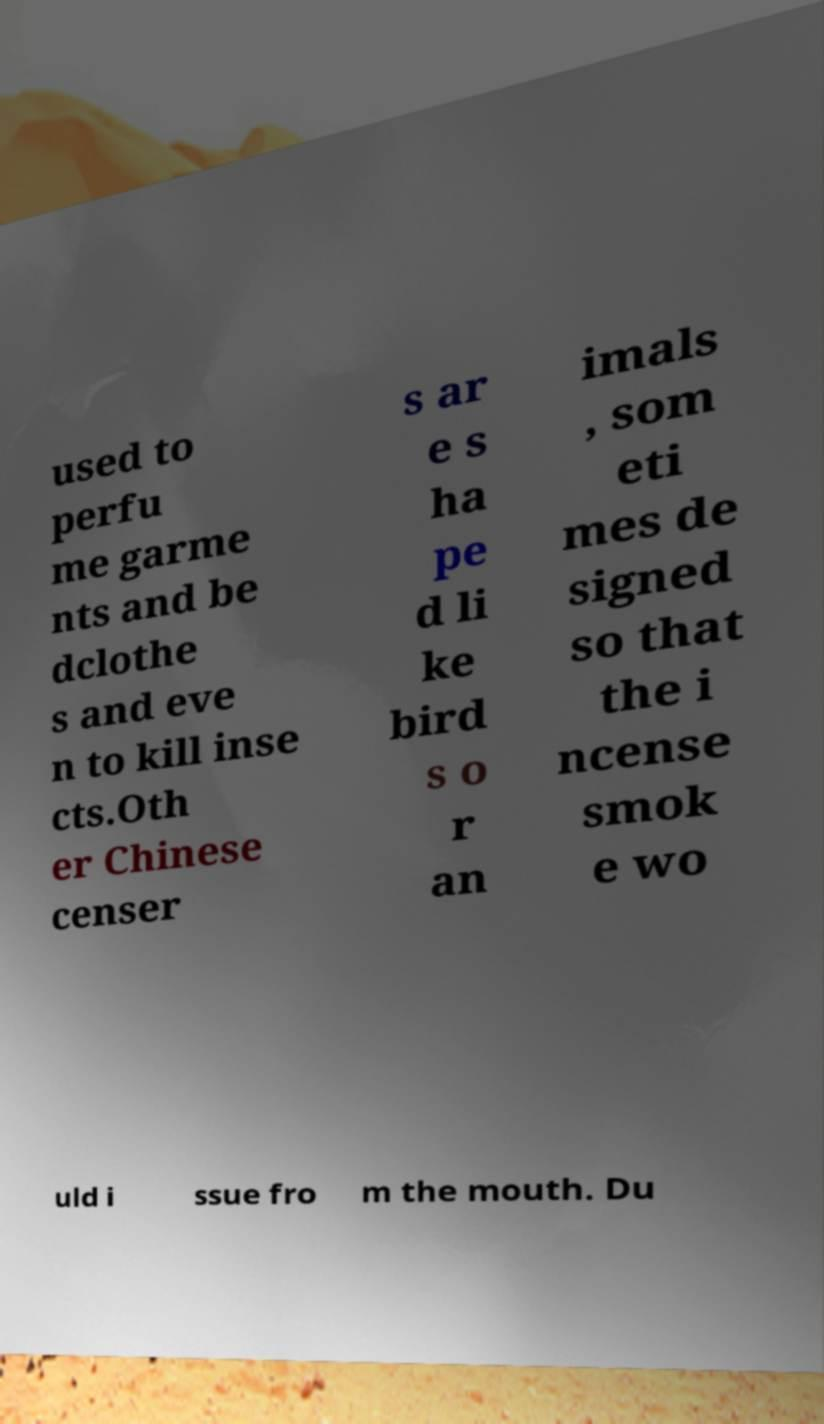Can you read and provide the text displayed in the image?This photo seems to have some interesting text. Can you extract and type it out for me? used to perfu me garme nts and be dclothe s and eve n to kill inse cts.Oth er Chinese censer s ar e s ha pe d li ke bird s o r an imals , som eti mes de signed so that the i ncense smok e wo uld i ssue fro m the mouth. Du 